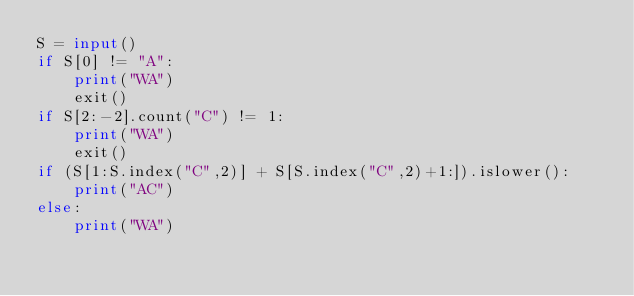Convert code to text. <code><loc_0><loc_0><loc_500><loc_500><_Python_>S = input()
if S[0] != "A":
    print("WA")
    exit()
if S[2:-2].count("C") != 1:
    print("WA")
    exit()
if (S[1:S.index("C",2)] + S[S.index("C",2)+1:]).islower():
    print("AC")
else:
    print("WA")</code> 